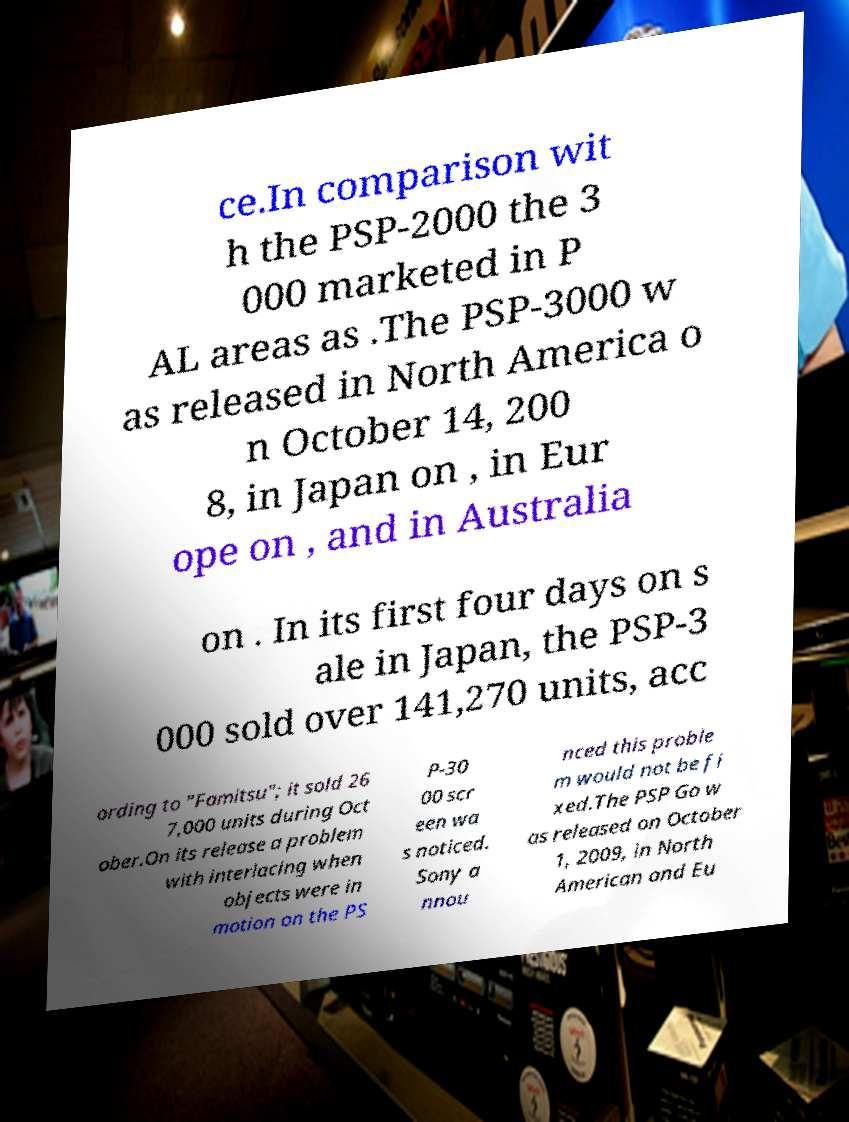Please identify and transcribe the text found in this image. ce.In comparison wit h the PSP-2000 the 3 000 marketed in P AL areas as .The PSP-3000 w as released in North America o n October 14, 200 8, in Japan on , in Eur ope on , and in Australia on . In its first four days on s ale in Japan, the PSP-3 000 sold over 141,270 units, acc ording to "Famitsu"; it sold 26 7,000 units during Oct ober.On its release a problem with interlacing when objects were in motion on the PS P-30 00 scr een wa s noticed. Sony a nnou nced this proble m would not be fi xed.The PSP Go w as released on October 1, 2009, in North American and Eu 